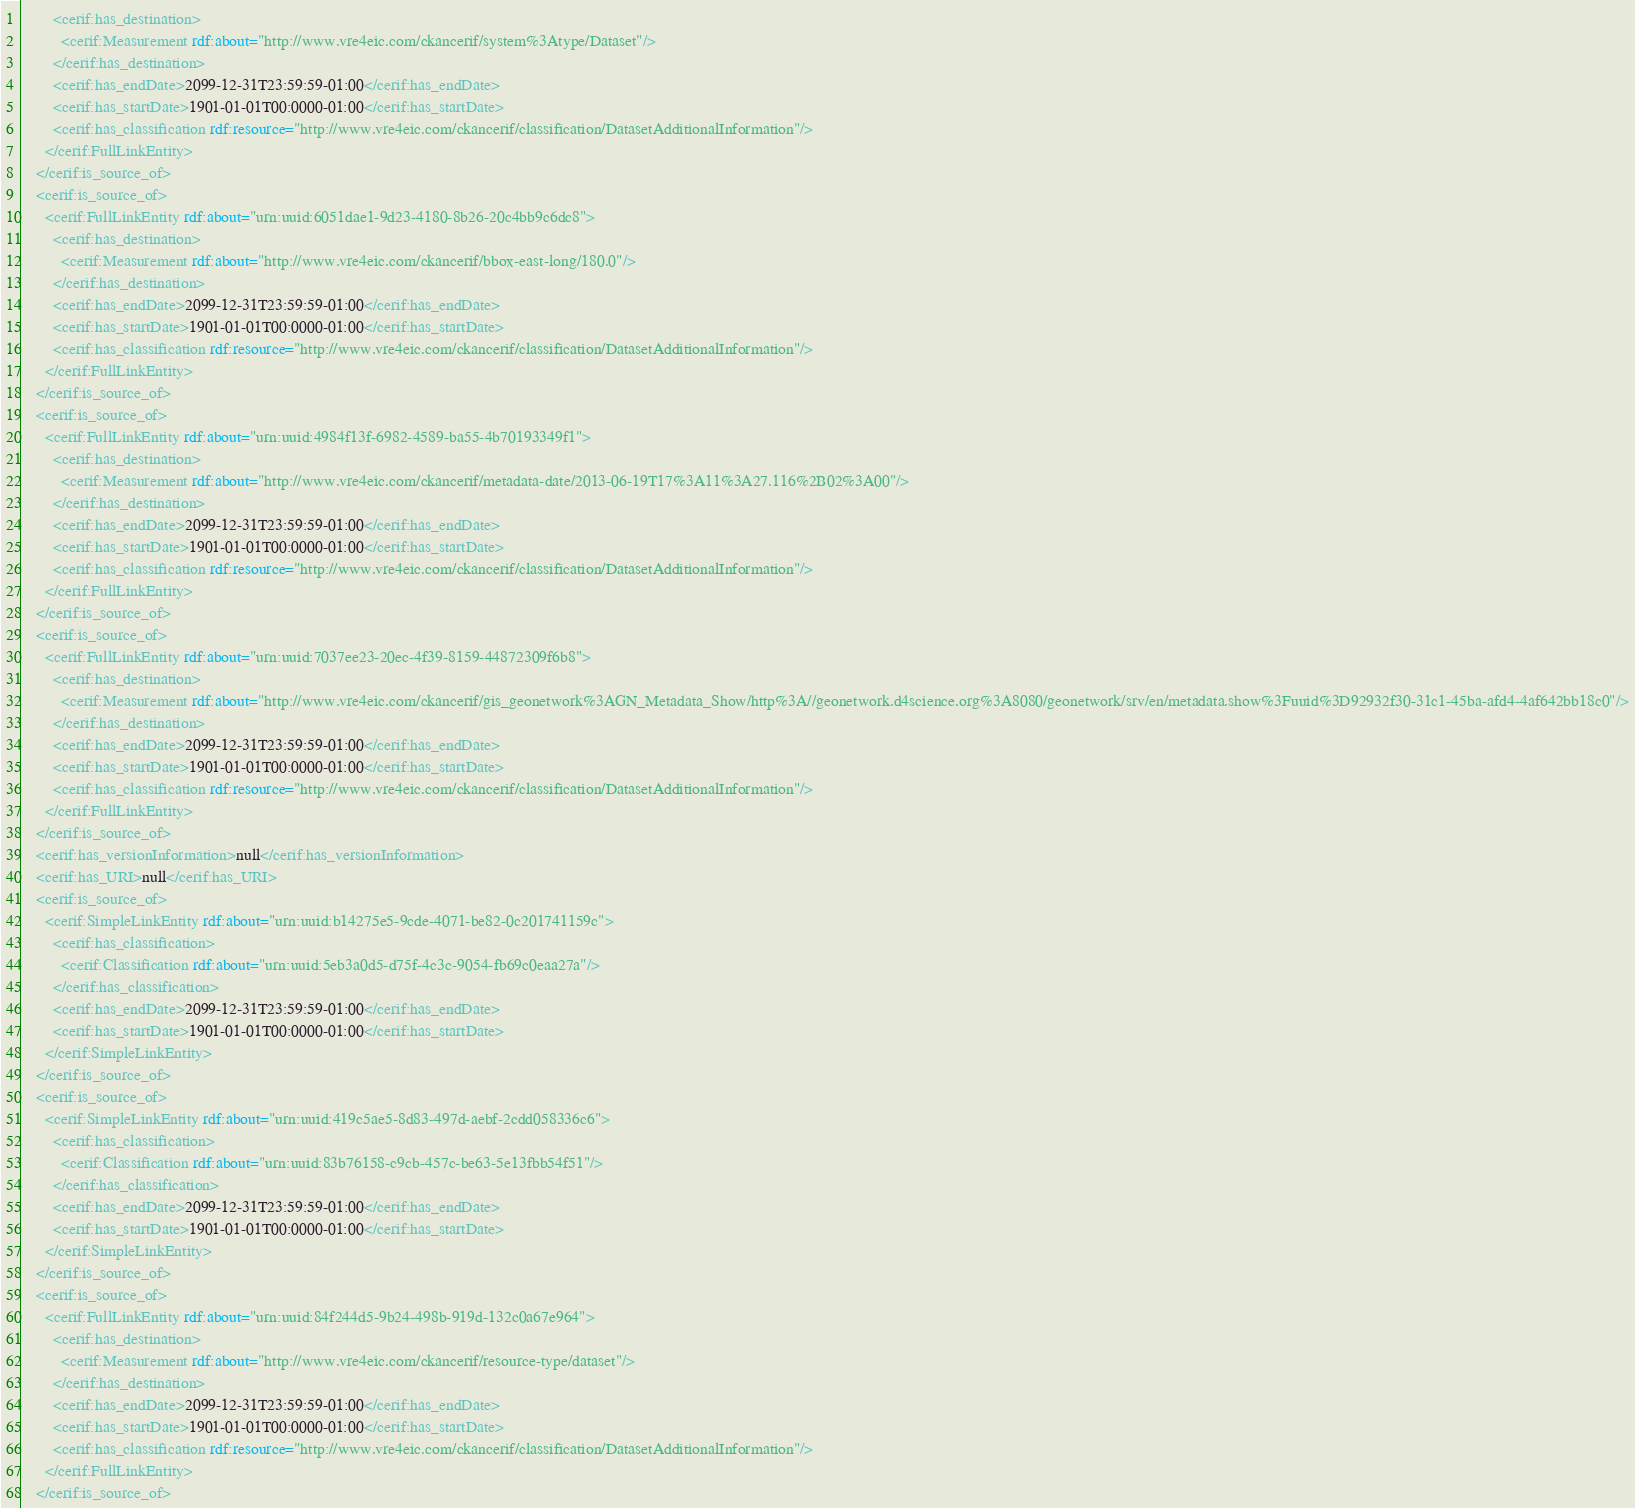<code> <loc_0><loc_0><loc_500><loc_500><_XML_>        <cerif:has_destination>
          <cerif:Measurement rdf:about="http://www.vre4eic.com/ckancerif/system%3Atype/Dataset"/>
        </cerif:has_destination>
        <cerif:has_endDate>2099-12-31T23:59:59-01:00</cerif:has_endDate>
        <cerif:has_startDate>1901-01-01T00:0000-01:00</cerif:has_startDate>
        <cerif:has_classification rdf:resource="http://www.vre4eic.com/ckancerif/classification/DatasetAdditionalInformation"/>
      </cerif:FullLinkEntity>
    </cerif:is_source_of>
    <cerif:is_source_of>
      <cerif:FullLinkEntity rdf:about="urn:uuid:6051dae1-9d23-4180-8b26-20c4bb9c6dc8">
        <cerif:has_destination>
          <cerif:Measurement rdf:about="http://www.vre4eic.com/ckancerif/bbox-east-long/180.0"/>
        </cerif:has_destination>
        <cerif:has_endDate>2099-12-31T23:59:59-01:00</cerif:has_endDate>
        <cerif:has_startDate>1901-01-01T00:0000-01:00</cerif:has_startDate>
        <cerif:has_classification rdf:resource="http://www.vre4eic.com/ckancerif/classification/DatasetAdditionalInformation"/>
      </cerif:FullLinkEntity>
    </cerif:is_source_of>
    <cerif:is_source_of>
      <cerif:FullLinkEntity rdf:about="urn:uuid:4984f13f-6982-4589-ba55-4b70193349f1">
        <cerif:has_destination>
          <cerif:Measurement rdf:about="http://www.vre4eic.com/ckancerif/metadata-date/2013-06-19T17%3A11%3A27.116%2B02%3A00"/>
        </cerif:has_destination>
        <cerif:has_endDate>2099-12-31T23:59:59-01:00</cerif:has_endDate>
        <cerif:has_startDate>1901-01-01T00:0000-01:00</cerif:has_startDate>
        <cerif:has_classification rdf:resource="http://www.vre4eic.com/ckancerif/classification/DatasetAdditionalInformation"/>
      </cerif:FullLinkEntity>
    </cerif:is_source_of>
    <cerif:is_source_of>
      <cerif:FullLinkEntity rdf:about="urn:uuid:7037ee23-20ec-4f39-8159-44872309f6b8">
        <cerif:has_destination>
          <cerif:Measurement rdf:about="http://www.vre4eic.com/ckancerif/gis_geonetwork%3AGN_Metadata_Show/http%3A//geonetwork.d4science.org%3A8080/geonetwork/srv/en/metadata.show%3Fuuid%3D92932f30-31c1-45ba-afd4-4af642bb18c0"/>
        </cerif:has_destination>
        <cerif:has_endDate>2099-12-31T23:59:59-01:00</cerif:has_endDate>
        <cerif:has_startDate>1901-01-01T00:0000-01:00</cerif:has_startDate>
        <cerif:has_classification rdf:resource="http://www.vre4eic.com/ckancerif/classification/DatasetAdditionalInformation"/>
      </cerif:FullLinkEntity>
    </cerif:is_source_of>
    <cerif:has_versionInformation>null</cerif:has_versionInformation>
    <cerif:has_URI>null</cerif:has_URI>
    <cerif:is_source_of>
      <cerif:SimpleLinkEntity rdf:about="urn:uuid:b14275e5-9cde-4071-be82-0c201741159c">
        <cerif:has_classification>
          <cerif:Classification rdf:about="urn:uuid:5eb3a0d5-d75f-4c3c-9054-fb69c0eaa27a"/>
        </cerif:has_classification>
        <cerif:has_endDate>2099-12-31T23:59:59-01:00</cerif:has_endDate>
        <cerif:has_startDate>1901-01-01T00:0000-01:00</cerif:has_startDate>
      </cerif:SimpleLinkEntity>
    </cerif:is_source_of>
    <cerif:is_source_of>
      <cerif:SimpleLinkEntity rdf:about="urn:uuid:419c5ae5-8d83-497d-aebf-2cdd058336c6">
        <cerif:has_classification>
          <cerif:Classification rdf:about="urn:uuid:83b76158-c9cb-457c-be63-5e13fbb54f51"/>
        </cerif:has_classification>
        <cerif:has_endDate>2099-12-31T23:59:59-01:00</cerif:has_endDate>
        <cerif:has_startDate>1901-01-01T00:0000-01:00</cerif:has_startDate>
      </cerif:SimpleLinkEntity>
    </cerif:is_source_of>
    <cerif:is_source_of>
      <cerif:FullLinkEntity rdf:about="urn:uuid:84f244d5-9b24-498b-919d-132c0a67e964">
        <cerif:has_destination>
          <cerif:Measurement rdf:about="http://www.vre4eic.com/ckancerif/resource-type/dataset"/>
        </cerif:has_destination>
        <cerif:has_endDate>2099-12-31T23:59:59-01:00</cerif:has_endDate>
        <cerif:has_startDate>1901-01-01T00:0000-01:00</cerif:has_startDate>
        <cerif:has_classification rdf:resource="http://www.vre4eic.com/ckancerif/classification/DatasetAdditionalInformation"/>
      </cerif:FullLinkEntity>
    </cerif:is_source_of></code> 